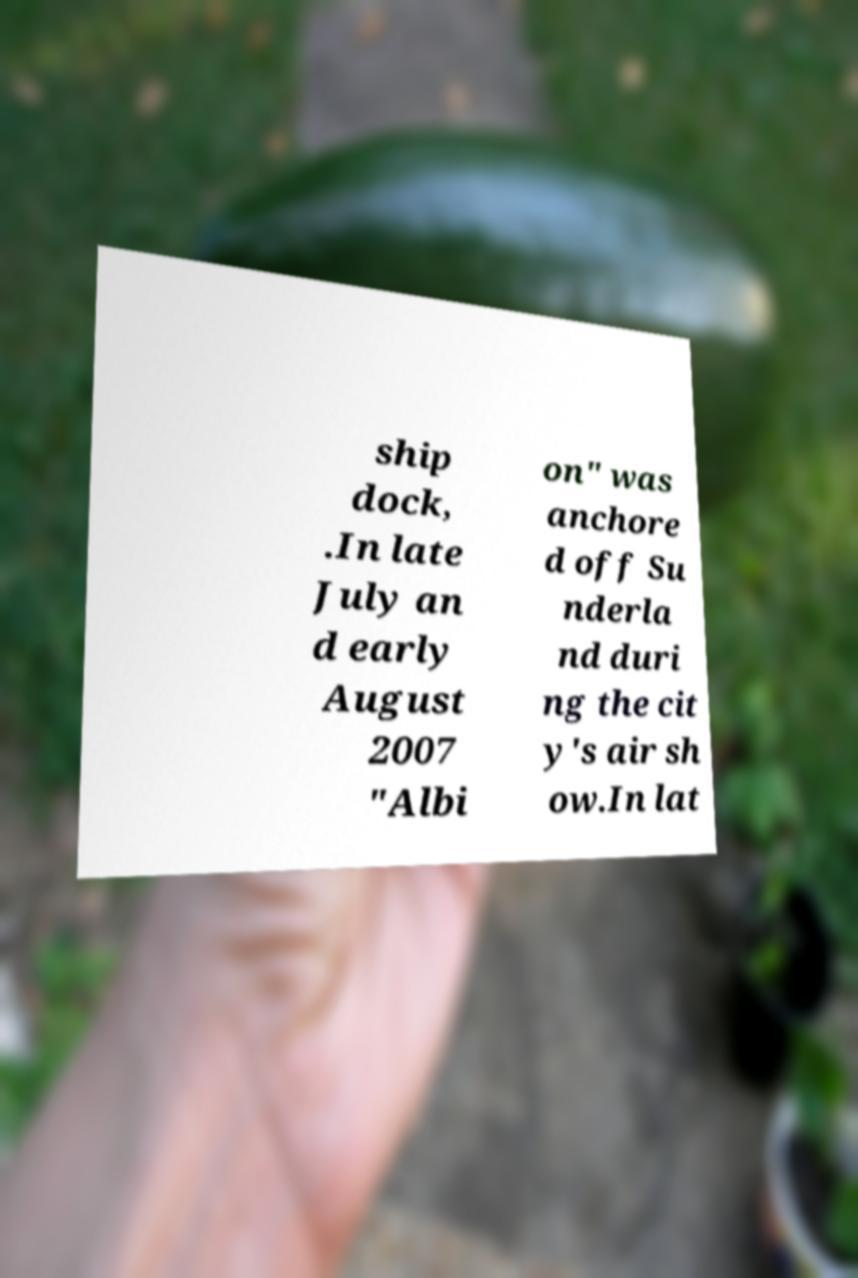I need the written content from this picture converted into text. Can you do that? ship dock, .In late July an d early August 2007 "Albi on" was anchore d off Su nderla nd duri ng the cit y's air sh ow.In lat 